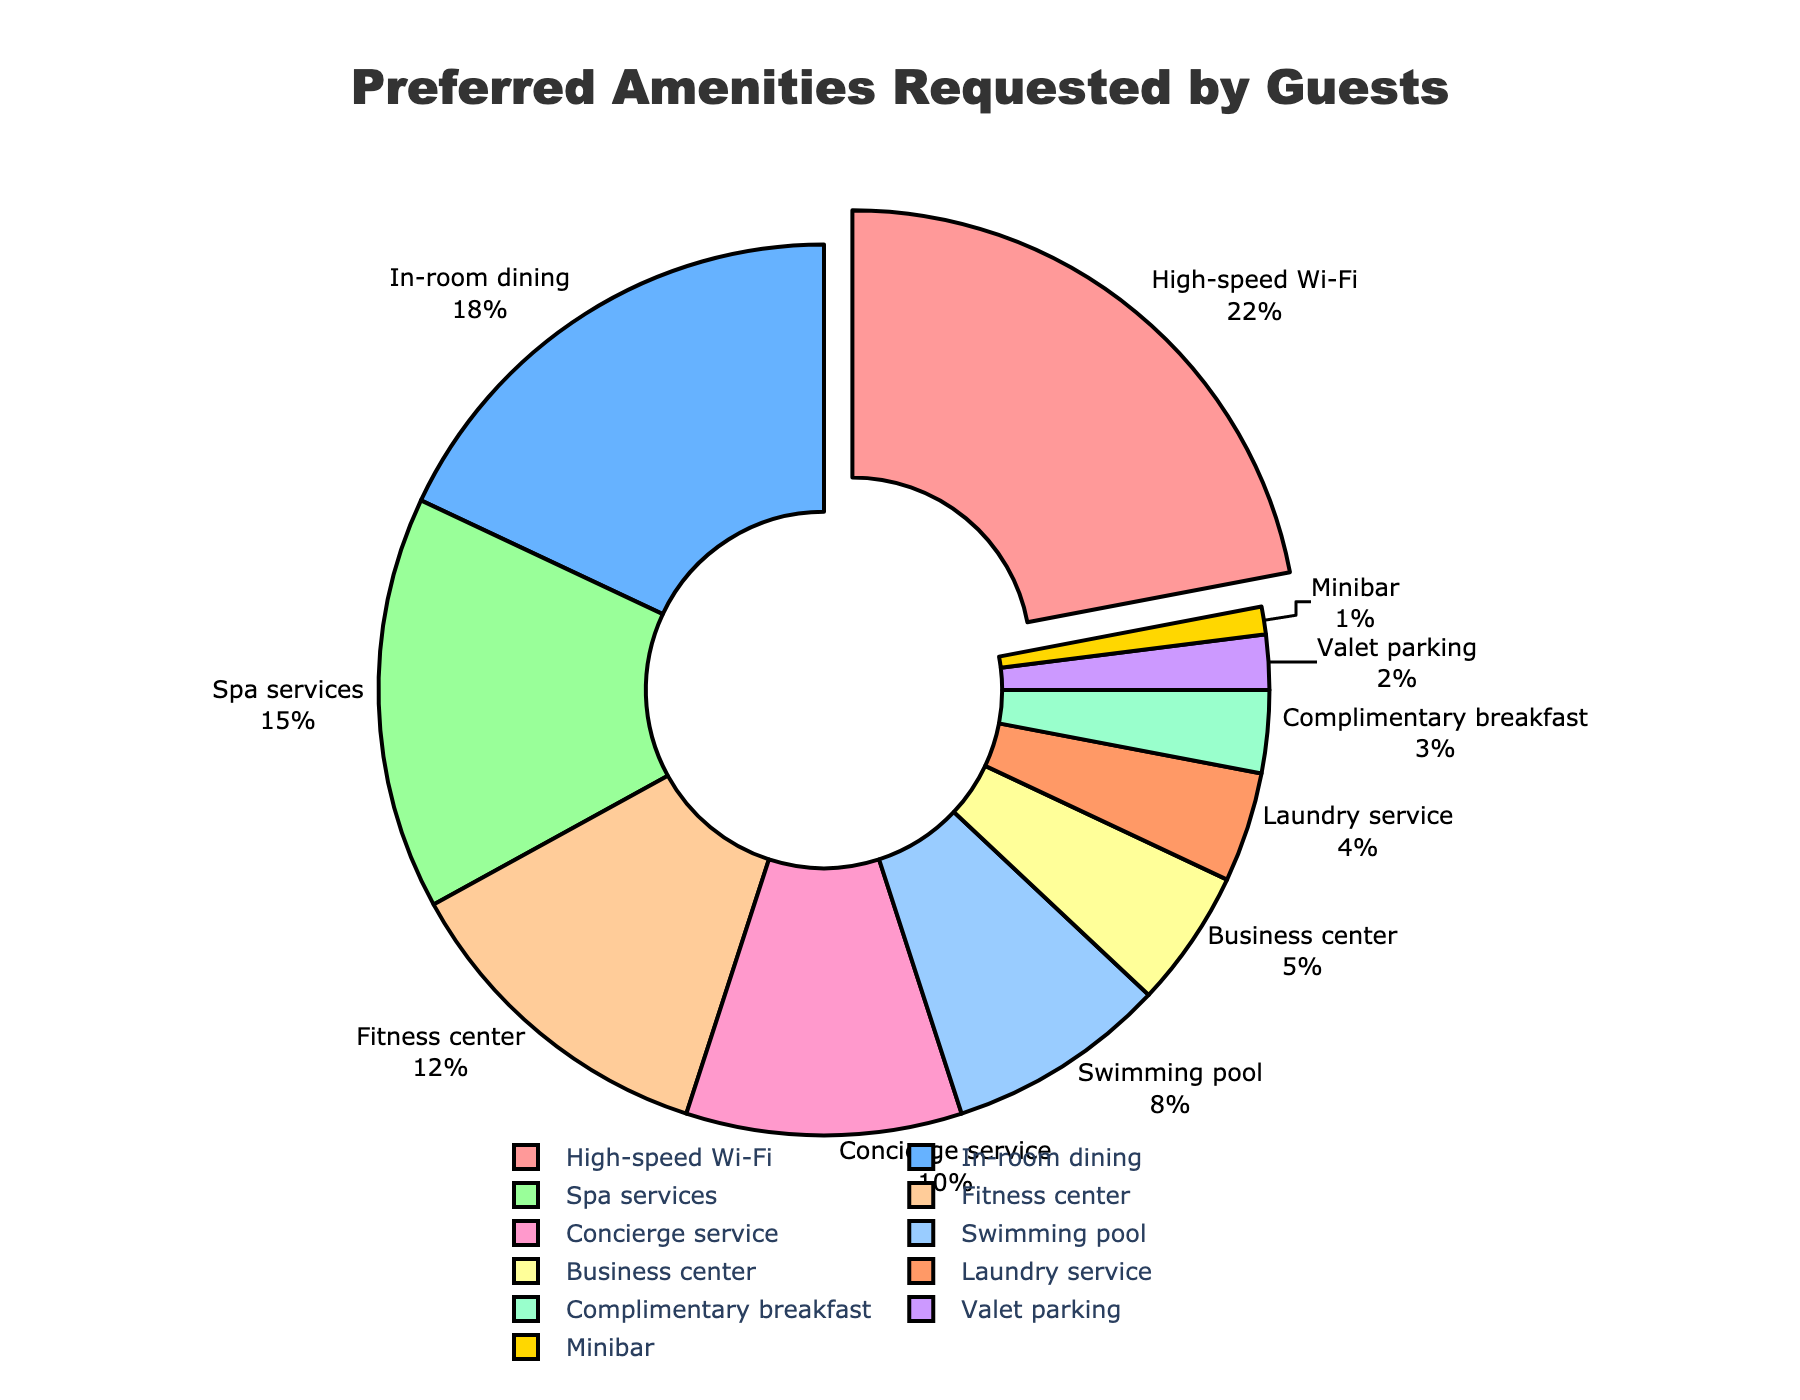What's the most requested amenity? By observing the pie chart, the biggest slice represents the most requested amenity. The label shows High-speed Wi-Fi requested by 22% of the guests, indicating it's the most requested amenity.
Answer: High-speed Wi-Fi What's the percentage difference between the most and least requested amenities? The most requested amenity is High-speed Wi-Fi (22%), and the least requested is Minibar (1%). The percentage difference is calculated as 22% - 1% = 21%.
Answer: 21% How many amenities have been requested by less than 10% of the guests? By counting the slices with percentages less than 10%, we find that there are six such amenities: Swimming pool (8%), Business center (5%), Laundry service (4%), Complimentary breakfast (3%), Valet parking (2%), and Minibar (1%).
Answer: 6 Which two amenities are most similarly requested? By comparing the percentages, we see that Valet parking (2%) and Minibar (1%) are closest in values, with only a 1% difference.
Answer: Valet parking and Minibar What percentage of guests requested Spa services and Fitness center combined? Spa services have 15% and Fitness center has 12%. Combining their percentages: 15% + 12% = 27%.
Answer: 27% Which amenities together constitute exactly 50% of the requests? Adding the percentages of the top three amenities: High-speed Wi-Fi (22%), In-room dining (18%), and Spa services (15%) sums to 55%. So, considering High-speed Wi-Fi (22%) and In-room dining (18%), and then adding Spa services sum is already above 50%. To find exact 50% or nearest, add the top two main requests: High-speed Wi-Fi (22%) and In-room dining (18% + 10%).
Answer: High-speed Wi-Fi and In-room dining What visual feature shows the most requested amenity in the chart? The most requested amenity is indicated by the segment that is slightly pulled out from the center of the pie. High-speed Wi-Fi slice is the one pulled out, indicating it is the most requested.
Answer: Segment is pulled out How much more popular is the Fitness center compared to Laundry service? Fitness center has 12% while Laundry service has 4%. The difference in popularity is calculated as 12% - 4% = 8%.
Answer: 8% What portion of the chart is dedicated to Concierge service? By looking at the pie chart, Concierge service represents 10% of the requests. This is confirmed by both the slice as well as the legend.
Answer: 10% What is the combined percentage of requests for in-room dining, spa services, and concierge service? Adding the percentages of In-room dining (18%), Spa services (15%), and Concierge service (10%): 18% + 15% + 10% = 43%.
Answer: 43% 